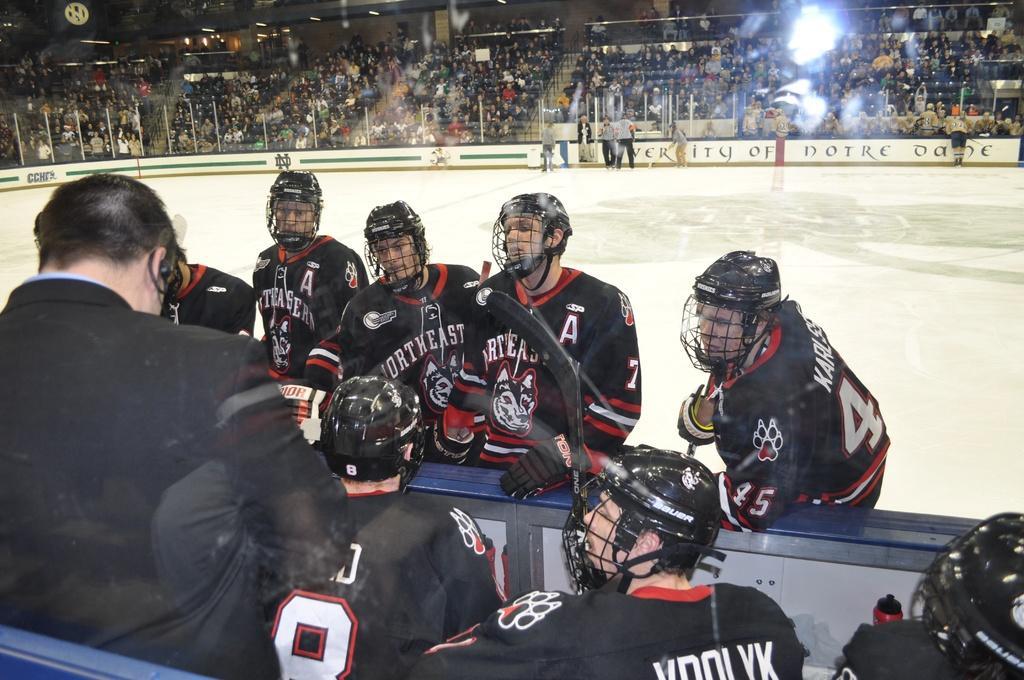In one or two sentences, can you explain what this image depicts? In the center of the image we can see a few people are in different costumes. Among them, we can see a few people are wearing helmets and gloves. And we can see some objects. In the background, we can see banners, few people are standing, few people are sitting and a few other objects. 